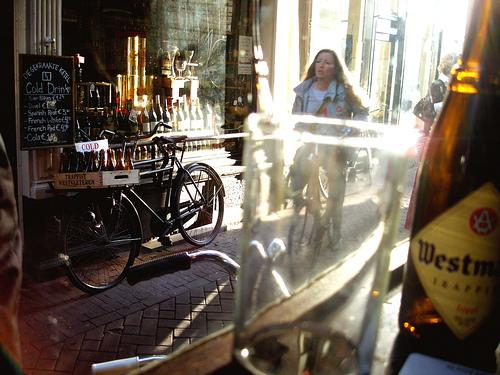This store likely sells what? alcohol 